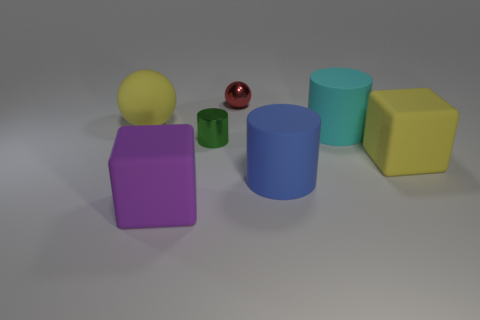Add 2 small green metallic things. How many objects exist? 9 Subtract all cubes. How many objects are left? 5 Subtract 0 green spheres. How many objects are left? 7 Subtract all tiny cubes. Subtract all yellow rubber things. How many objects are left? 5 Add 5 green objects. How many green objects are left? 6 Add 1 red shiny objects. How many red shiny objects exist? 2 